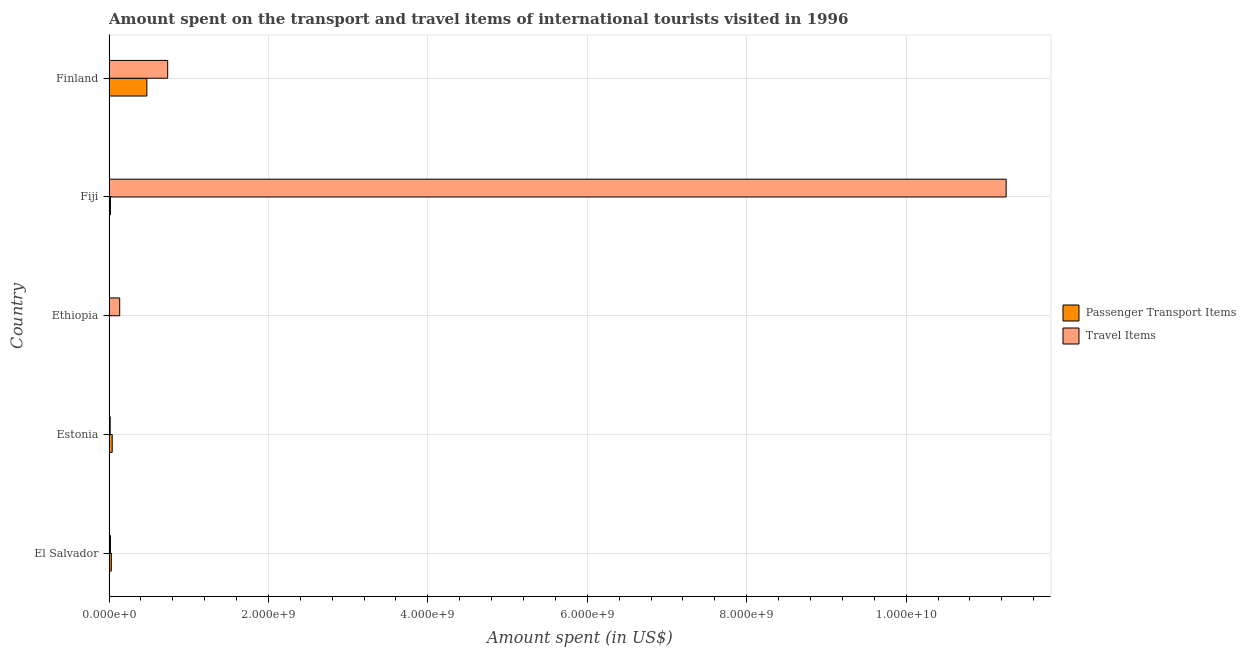How many bars are there on the 2nd tick from the top?
Give a very brief answer. 2. How many bars are there on the 2nd tick from the bottom?
Provide a succinct answer. 2. What is the label of the 2nd group of bars from the top?
Provide a succinct answer. Fiji. In how many cases, is the number of bars for a given country not equal to the number of legend labels?
Offer a terse response. 0. Across all countries, what is the maximum amount spent in travel items?
Offer a very short reply. 1.13e+1. Across all countries, what is the minimum amount spent in travel items?
Offer a very short reply. 1.50e+07. In which country was the amount spent in travel items minimum?
Ensure brevity in your answer.  Estonia. What is the total amount spent in travel items in the graph?
Your answer should be compact. 1.22e+1. What is the difference between the amount spent in travel items in El Salvador and that in Finland?
Your answer should be very brief. -7.18e+08. What is the average amount spent in travel items per country?
Offer a very short reply. 2.43e+09. What is the difference between the amount spent in travel items and amount spent on passenger transport items in Fiji?
Your answer should be very brief. 1.12e+1. In how many countries, is the amount spent on passenger transport items greater than 2800000000 US$?
Keep it short and to the point. 0. What is the ratio of the amount spent on passenger transport items in El Salvador to that in Finland?
Provide a succinct answer. 0.06. What is the difference between the highest and the second highest amount spent on passenger transport items?
Your answer should be compact. 4.35e+08. What is the difference between the highest and the lowest amount spent in travel items?
Keep it short and to the point. 1.12e+1. In how many countries, is the amount spent on passenger transport items greater than the average amount spent on passenger transport items taken over all countries?
Provide a short and direct response. 1. What does the 2nd bar from the top in Estonia represents?
Provide a short and direct response. Passenger Transport Items. What does the 1st bar from the bottom in Ethiopia represents?
Provide a short and direct response. Passenger Transport Items. Are all the bars in the graph horizontal?
Provide a succinct answer. Yes. Does the graph contain grids?
Ensure brevity in your answer.  Yes. How many legend labels are there?
Provide a succinct answer. 2. How are the legend labels stacked?
Your answer should be very brief. Vertical. What is the title of the graph?
Make the answer very short. Amount spent on the transport and travel items of international tourists visited in 1996. Does "Merchandise imports" appear as one of the legend labels in the graph?
Provide a succinct answer. No. What is the label or title of the X-axis?
Make the answer very short. Amount spent (in US$). What is the label or title of the Y-axis?
Offer a very short reply. Country. What is the Amount spent (in US$) of Passenger Transport Items in El Salvador?
Provide a succinct answer. 2.90e+07. What is the Amount spent (in US$) in Travel Items in El Salvador?
Provide a short and direct response. 1.80e+07. What is the Amount spent (in US$) of Passenger Transport Items in Estonia?
Ensure brevity in your answer.  4.00e+07. What is the Amount spent (in US$) of Travel Items in Estonia?
Provide a succinct answer. 1.50e+07. What is the Amount spent (in US$) in Passenger Transport Items in Ethiopia?
Offer a very short reply. 5.00e+06. What is the Amount spent (in US$) in Travel Items in Ethiopia?
Offer a terse response. 1.34e+08. What is the Amount spent (in US$) in Passenger Transport Items in Fiji?
Keep it short and to the point. 1.80e+07. What is the Amount spent (in US$) in Travel Items in Fiji?
Make the answer very short. 1.13e+1. What is the Amount spent (in US$) in Passenger Transport Items in Finland?
Keep it short and to the point. 4.75e+08. What is the Amount spent (in US$) in Travel Items in Finland?
Keep it short and to the point. 7.36e+08. Across all countries, what is the maximum Amount spent (in US$) in Passenger Transport Items?
Your response must be concise. 4.75e+08. Across all countries, what is the maximum Amount spent (in US$) in Travel Items?
Ensure brevity in your answer.  1.13e+1. Across all countries, what is the minimum Amount spent (in US$) of Travel Items?
Provide a succinct answer. 1.50e+07. What is the total Amount spent (in US$) of Passenger Transport Items in the graph?
Ensure brevity in your answer.  5.67e+08. What is the total Amount spent (in US$) of Travel Items in the graph?
Ensure brevity in your answer.  1.22e+1. What is the difference between the Amount spent (in US$) of Passenger Transport Items in El Salvador and that in Estonia?
Your answer should be compact. -1.10e+07. What is the difference between the Amount spent (in US$) of Travel Items in El Salvador and that in Estonia?
Give a very brief answer. 3.00e+06. What is the difference between the Amount spent (in US$) of Passenger Transport Items in El Salvador and that in Ethiopia?
Ensure brevity in your answer.  2.40e+07. What is the difference between the Amount spent (in US$) in Travel Items in El Salvador and that in Ethiopia?
Your answer should be very brief. -1.16e+08. What is the difference between the Amount spent (in US$) of Passenger Transport Items in El Salvador and that in Fiji?
Your response must be concise. 1.10e+07. What is the difference between the Amount spent (in US$) in Travel Items in El Salvador and that in Fiji?
Make the answer very short. -1.12e+1. What is the difference between the Amount spent (in US$) in Passenger Transport Items in El Salvador and that in Finland?
Offer a terse response. -4.46e+08. What is the difference between the Amount spent (in US$) of Travel Items in El Salvador and that in Finland?
Provide a succinct answer. -7.18e+08. What is the difference between the Amount spent (in US$) in Passenger Transport Items in Estonia and that in Ethiopia?
Offer a terse response. 3.50e+07. What is the difference between the Amount spent (in US$) of Travel Items in Estonia and that in Ethiopia?
Your response must be concise. -1.19e+08. What is the difference between the Amount spent (in US$) of Passenger Transport Items in Estonia and that in Fiji?
Offer a very short reply. 2.20e+07. What is the difference between the Amount spent (in US$) in Travel Items in Estonia and that in Fiji?
Your response must be concise. -1.12e+1. What is the difference between the Amount spent (in US$) in Passenger Transport Items in Estonia and that in Finland?
Provide a short and direct response. -4.35e+08. What is the difference between the Amount spent (in US$) in Travel Items in Estonia and that in Finland?
Ensure brevity in your answer.  -7.21e+08. What is the difference between the Amount spent (in US$) in Passenger Transport Items in Ethiopia and that in Fiji?
Provide a succinct answer. -1.30e+07. What is the difference between the Amount spent (in US$) of Travel Items in Ethiopia and that in Fiji?
Your answer should be compact. -1.11e+1. What is the difference between the Amount spent (in US$) of Passenger Transport Items in Ethiopia and that in Finland?
Ensure brevity in your answer.  -4.70e+08. What is the difference between the Amount spent (in US$) of Travel Items in Ethiopia and that in Finland?
Provide a succinct answer. -6.02e+08. What is the difference between the Amount spent (in US$) of Passenger Transport Items in Fiji and that in Finland?
Give a very brief answer. -4.57e+08. What is the difference between the Amount spent (in US$) in Travel Items in Fiji and that in Finland?
Offer a very short reply. 1.05e+1. What is the difference between the Amount spent (in US$) of Passenger Transport Items in El Salvador and the Amount spent (in US$) of Travel Items in Estonia?
Offer a very short reply. 1.40e+07. What is the difference between the Amount spent (in US$) in Passenger Transport Items in El Salvador and the Amount spent (in US$) in Travel Items in Ethiopia?
Offer a very short reply. -1.05e+08. What is the difference between the Amount spent (in US$) in Passenger Transport Items in El Salvador and the Amount spent (in US$) in Travel Items in Fiji?
Offer a very short reply. -1.12e+1. What is the difference between the Amount spent (in US$) of Passenger Transport Items in El Salvador and the Amount spent (in US$) of Travel Items in Finland?
Ensure brevity in your answer.  -7.07e+08. What is the difference between the Amount spent (in US$) in Passenger Transport Items in Estonia and the Amount spent (in US$) in Travel Items in Ethiopia?
Make the answer very short. -9.40e+07. What is the difference between the Amount spent (in US$) of Passenger Transport Items in Estonia and the Amount spent (in US$) of Travel Items in Fiji?
Offer a very short reply. -1.12e+1. What is the difference between the Amount spent (in US$) in Passenger Transport Items in Estonia and the Amount spent (in US$) in Travel Items in Finland?
Make the answer very short. -6.96e+08. What is the difference between the Amount spent (in US$) of Passenger Transport Items in Ethiopia and the Amount spent (in US$) of Travel Items in Fiji?
Your response must be concise. -1.12e+1. What is the difference between the Amount spent (in US$) of Passenger Transport Items in Ethiopia and the Amount spent (in US$) of Travel Items in Finland?
Offer a terse response. -7.31e+08. What is the difference between the Amount spent (in US$) of Passenger Transport Items in Fiji and the Amount spent (in US$) of Travel Items in Finland?
Offer a terse response. -7.18e+08. What is the average Amount spent (in US$) of Passenger Transport Items per country?
Your answer should be very brief. 1.13e+08. What is the average Amount spent (in US$) in Travel Items per country?
Offer a terse response. 2.43e+09. What is the difference between the Amount spent (in US$) of Passenger Transport Items and Amount spent (in US$) of Travel Items in El Salvador?
Provide a succinct answer. 1.10e+07. What is the difference between the Amount spent (in US$) in Passenger Transport Items and Amount spent (in US$) in Travel Items in Estonia?
Offer a terse response. 2.50e+07. What is the difference between the Amount spent (in US$) of Passenger Transport Items and Amount spent (in US$) of Travel Items in Ethiopia?
Offer a terse response. -1.29e+08. What is the difference between the Amount spent (in US$) of Passenger Transport Items and Amount spent (in US$) of Travel Items in Fiji?
Your response must be concise. -1.12e+1. What is the difference between the Amount spent (in US$) of Passenger Transport Items and Amount spent (in US$) of Travel Items in Finland?
Give a very brief answer. -2.61e+08. What is the ratio of the Amount spent (in US$) in Passenger Transport Items in El Salvador to that in Estonia?
Your answer should be compact. 0.72. What is the ratio of the Amount spent (in US$) of Travel Items in El Salvador to that in Estonia?
Your answer should be very brief. 1.2. What is the ratio of the Amount spent (in US$) in Travel Items in El Salvador to that in Ethiopia?
Offer a terse response. 0.13. What is the ratio of the Amount spent (in US$) in Passenger Transport Items in El Salvador to that in Fiji?
Your response must be concise. 1.61. What is the ratio of the Amount spent (in US$) of Travel Items in El Salvador to that in Fiji?
Provide a short and direct response. 0. What is the ratio of the Amount spent (in US$) in Passenger Transport Items in El Salvador to that in Finland?
Your answer should be compact. 0.06. What is the ratio of the Amount spent (in US$) of Travel Items in El Salvador to that in Finland?
Your answer should be compact. 0.02. What is the ratio of the Amount spent (in US$) in Travel Items in Estonia to that in Ethiopia?
Offer a very short reply. 0.11. What is the ratio of the Amount spent (in US$) in Passenger Transport Items in Estonia to that in Fiji?
Your answer should be compact. 2.22. What is the ratio of the Amount spent (in US$) in Travel Items in Estonia to that in Fiji?
Ensure brevity in your answer.  0. What is the ratio of the Amount spent (in US$) of Passenger Transport Items in Estonia to that in Finland?
Keep it short and to the point. 0.08. What is the ratio of the Amount spent (in US$) of Travel Items in Estonia to that in Finland?
Keep it short and to the point. 0.02. What is the ratio of the Amount spent (in US$) of Passenger Transport Items in Ethiopia to that in Fiji?
Make the answer very short. 0.28. What is the ratio of the Amount spent (in US$) in Travel Items in Ethiopia to that in Fiji?
Give a very brief answer. 0.01. What is the ratio of the Amount spent (in US$) in Passenger Transport Items in Ethiopia to that in Finland?
Ensure brevity in your answer.  0.01. What is the ratio of the Amount spent (in US$) of Travel Items in Ethiopia to that in Finland?
Keep it short and to the point. 0.18. What is the ratio of the Amount spent (in US$) of Passenger Transport Items in Fiji to that in Finland?
Make the answer very short. 0.04. What is the ratio of the Amount spent (in US$) in Travel Items in Fiji to that in Finland?
Ensure brevity in your answer.  15.29. What is the difference between the highest and the second highest Amount spent (in US$) of Passenger Transport Items?
Make the answer very short. 4.35e+08. What is the difference between the highest and the second highest Amount spent (in US$) of Travel Items?
Your response must be concise. 1.05e+1. What is the difference between the highest and the lowest Amount spent (in US$) in Passenger Transport Items?
Your response must be concise. 4.70e+08. What is the difference between the highest and the lowest Amount spent (in US$) of Travel Items?
Offer a terse response. 1.12e+1. 